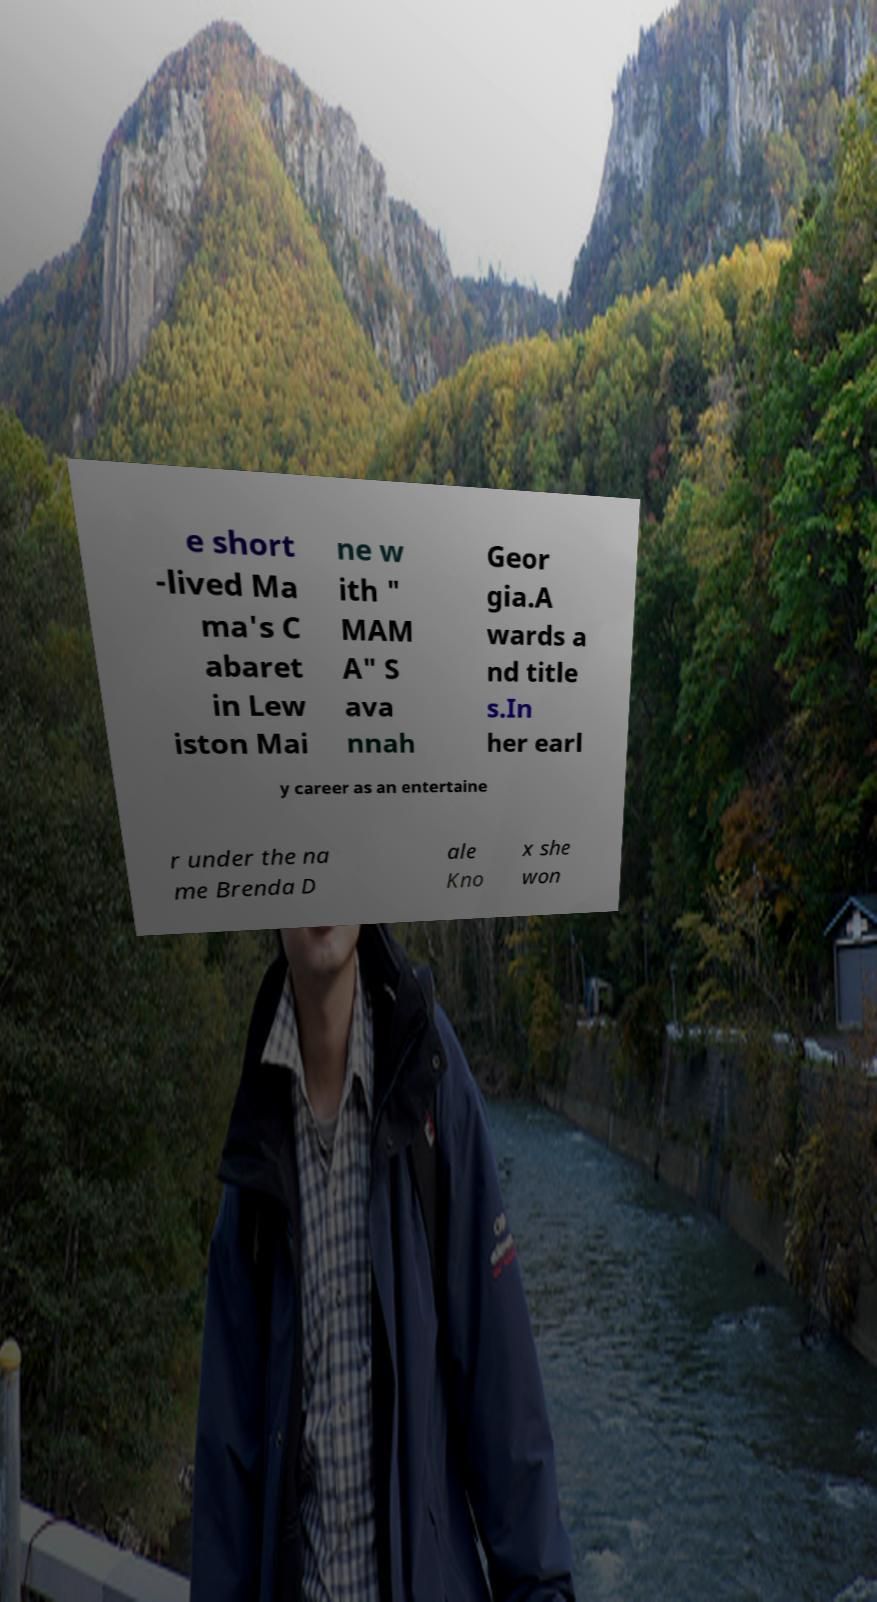Can you accurately transcribe the text from the provided image for me? e short -lived Ma ma's C abaret in Lew iston Mai ne w ith " MAM A" S ava nnah Geor gia.A wards a nd title s.In her earl y career as an entertaine r under the na me Brenda D ale Kno x she won 